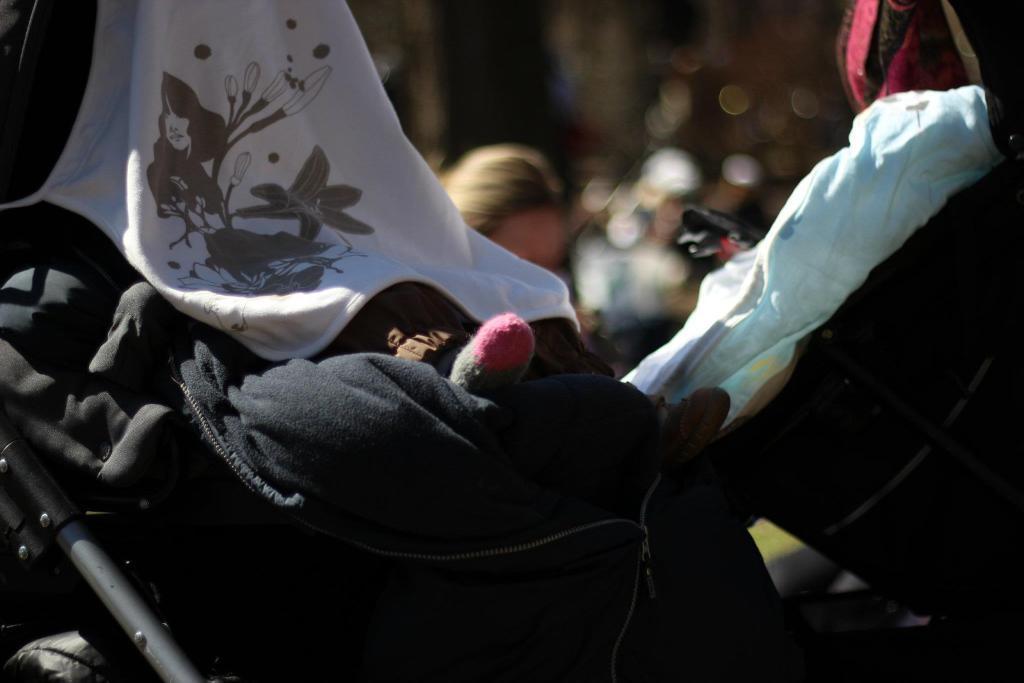Describe this image in one or two sentences. In the center of the image we can see a pram and there are clothes placed on it. In the background there is a person. 